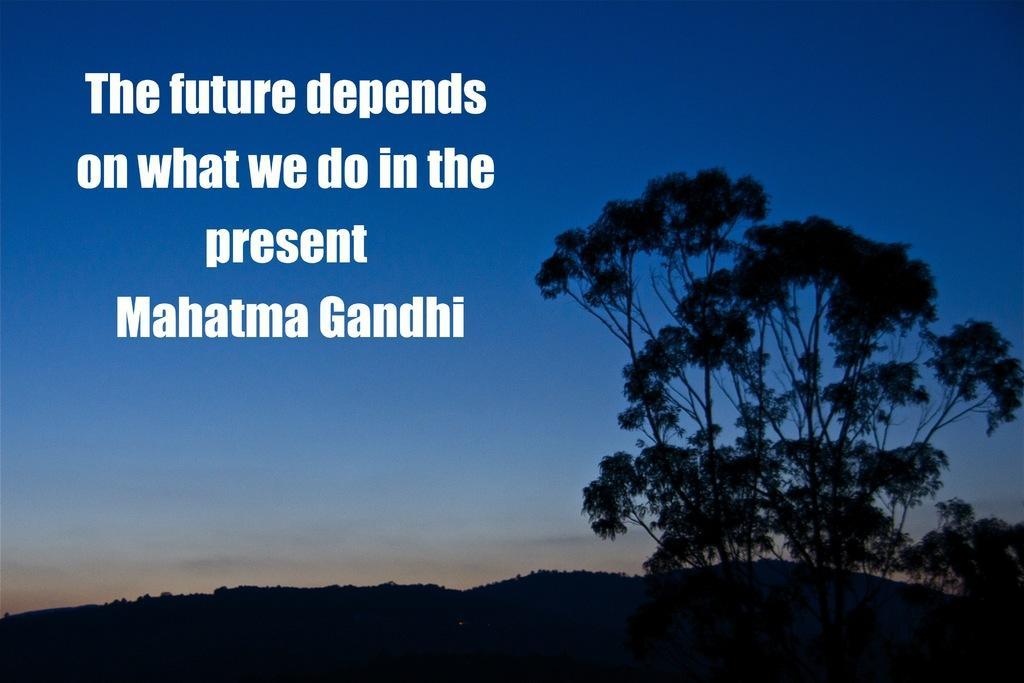Please provide a concise description of this image. In this image there are trees, mountains and the sky. In the foreground of the image there is some text. 